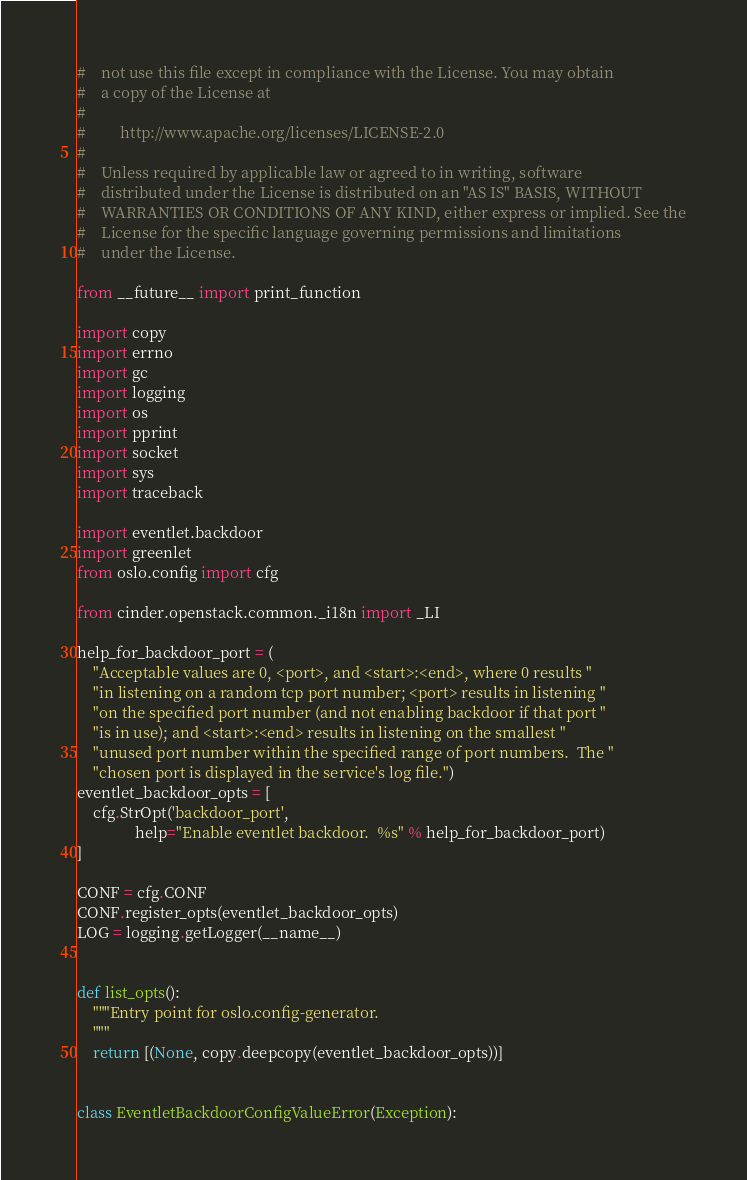Convert code to text. <code><loc_0><loc_0><loc_500><loc_500><_Python_>#    not use this file except in compliance with the License. You may obtain
#    a copy of the License at
#
#         http://www.apache.org/licenses/LICENSE-2.0
#
#    Unless required by applicable law or agreed to in writing, software
#    distributed under the License is distributed on an "AS IS" BASIS, WITHOUT
#    WARRANTIES OR CONDITIONS OF ANY KIND, either express or implied. See the
#    License for the specific language governing permissions and limitations
#    under the License.

from __future__ import print_function

import copy
import errno
import gc
import logging
import os
import pprint
import socket
import sys
import traceback

import eventlet.backdoor
import greenlet
from oslo.config import cfg

from cinder.openstack.common._i18n import _LI

help_for_backdoor_port = (
    "Acceptable values are 0, <port>, and <start>:<end>, where 0 results "
    "in listening on a random tcp port number; <port> results in listening "
    "on the specified port number (and not enabling backdoor if that port "
    "is in use); and <start>:<end> results in listening on the smallest "
    "unused port number within the specified range of port numbers.  The "
    "chosen port is displayed in the service's log file.")
eventlet_backdoor_opts = [
    cfg.StrOpt('backdoor_port',
               help="Enable eventlet backdoor.  %s" % help_for_backdoor_port)
]

CONF = cfg.CONF
CONF.register_opts(eventlet_backdoor_opts)
LOG = logging.getLogger(__name__)


def list_opts():
    """Entry point for oslo.config-generator.
    """
    return [(None, copy.deepcopy(eventlet_backdoor_opts))]


class EventletBackdoorConfigValueError(Exception):</code> 